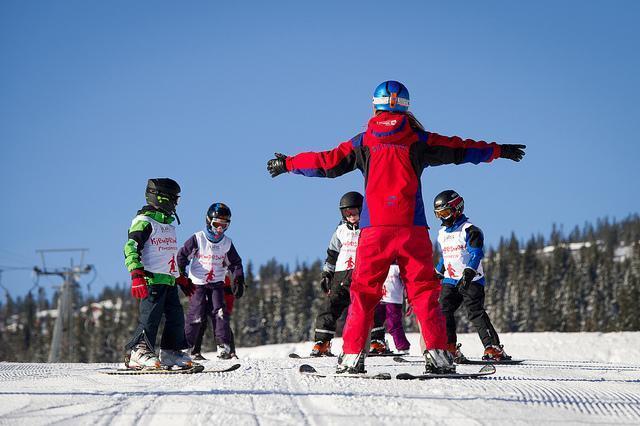How many skiers do you see?
Give a very brief answer. 6. How many people are there?
Give a very brief answer. 6. 